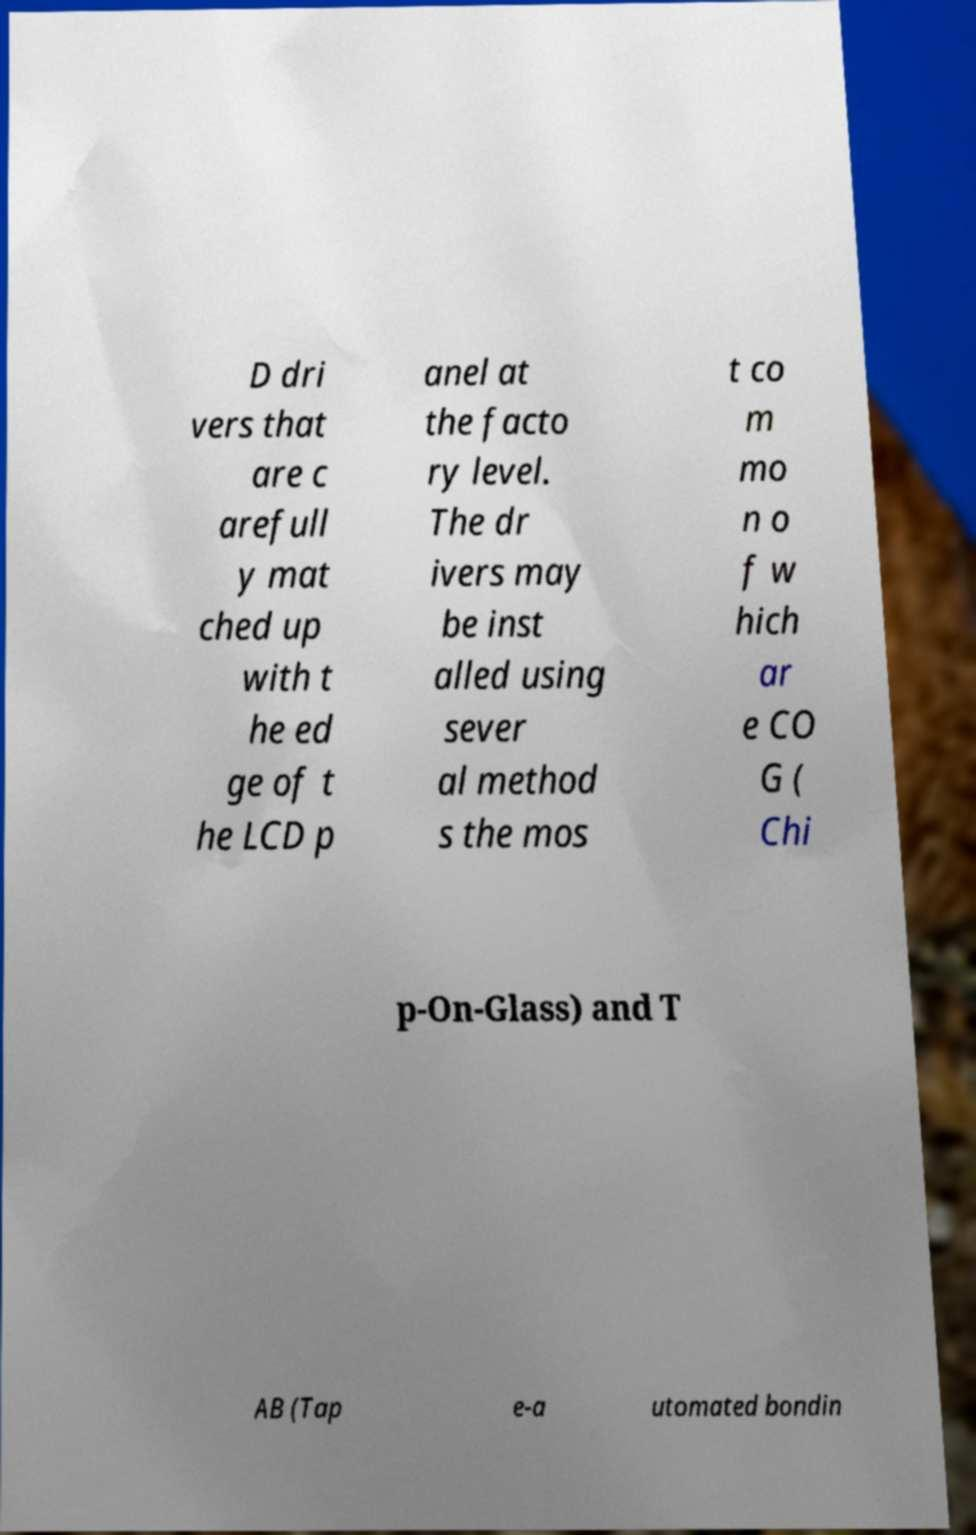Could you assist in decoding the text presented in this image and type it out clearly? D dri vers that are c arefull y mat ched up with t he ed ge of t he LCD p anel at the facto ry level. The dr ivers may be inst alled using sever al method s the mos t co m mo n o f w hich ar e CO G ( Chi p-On-Glass) and T AB (Tap e-a utomated bondin 